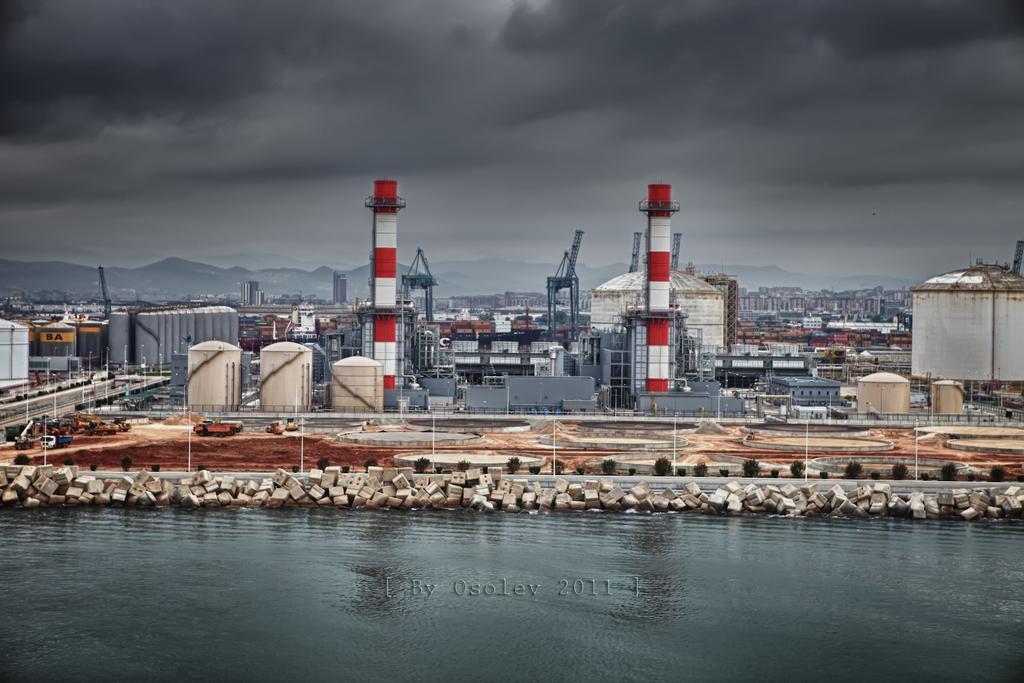In one or two sentences, can you explain what this image depicts? In the center of the image we can see power station. At the bottom there is water and we can see rocks. There are vehicles. In the background there are hills and sky. 